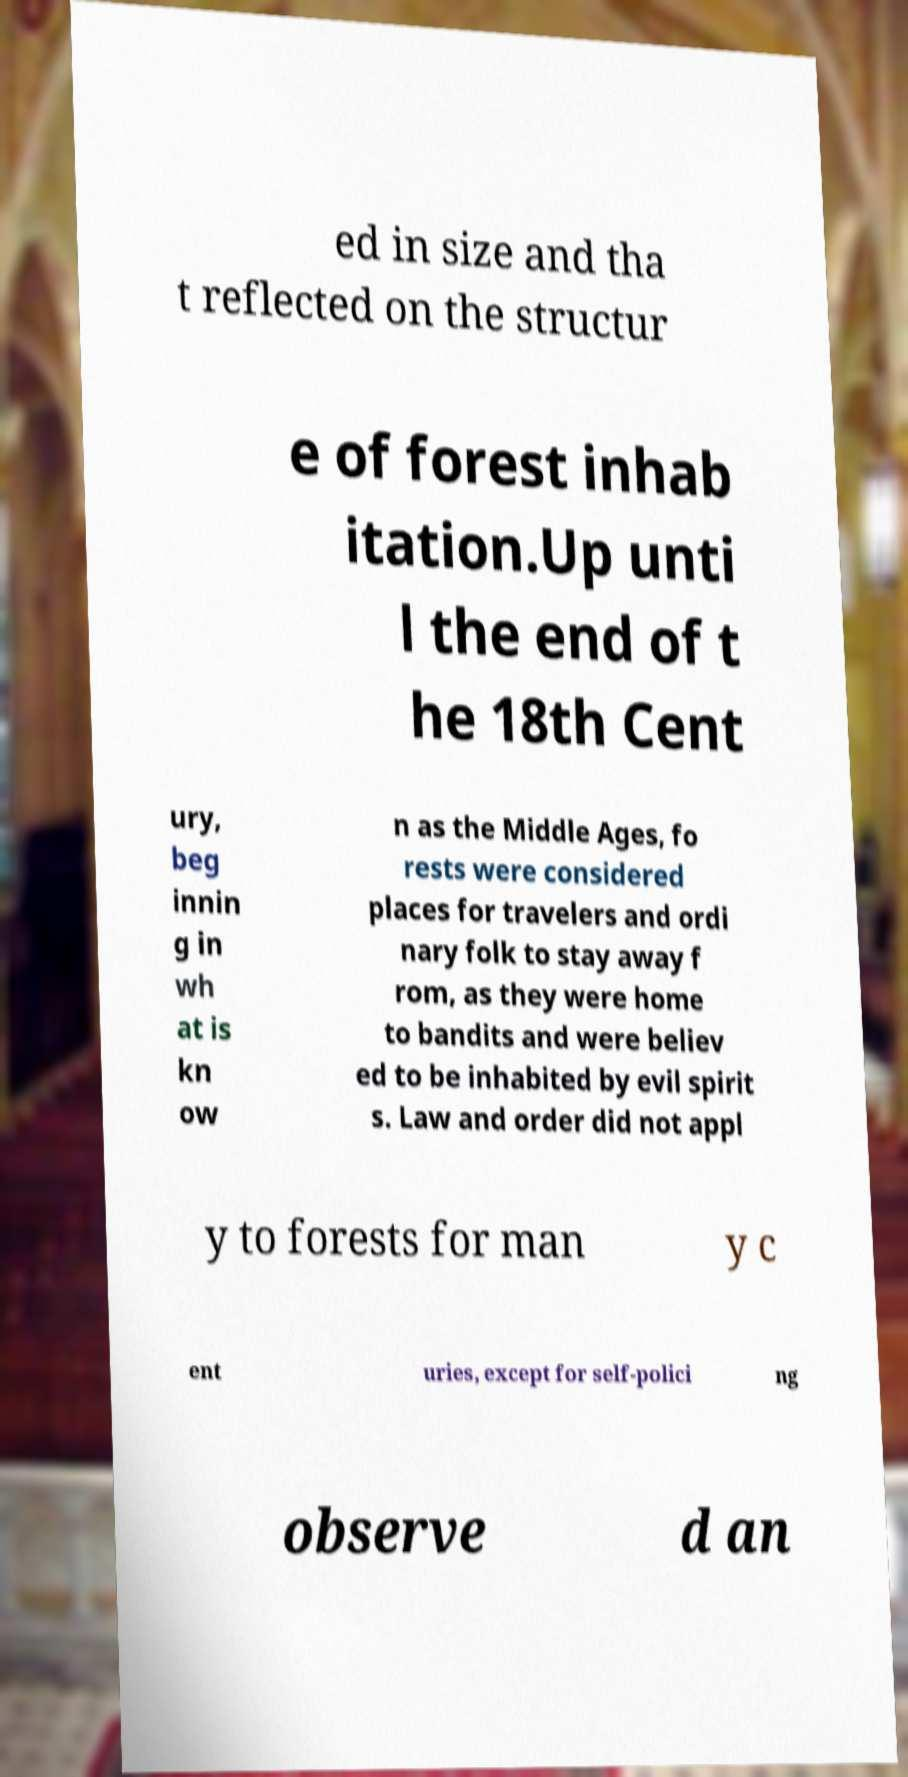Could you assist in decoding the text presented in this image and type it out clearly? ed in size and tha t reflected on the structur e of forest inhab itation.Up unti l the end of t he 18th Cent ury, beg innin g in wh at is kn ow n as the Middle Ages, fo rests were considered places for travelers and ordi nary folk to stay away f rom, as they were home to bandits and were believ ed to be inhabited by evil spirit s. Law and order did not appl y to forests for man y c ent uries, except for self-polici ng observe d an 